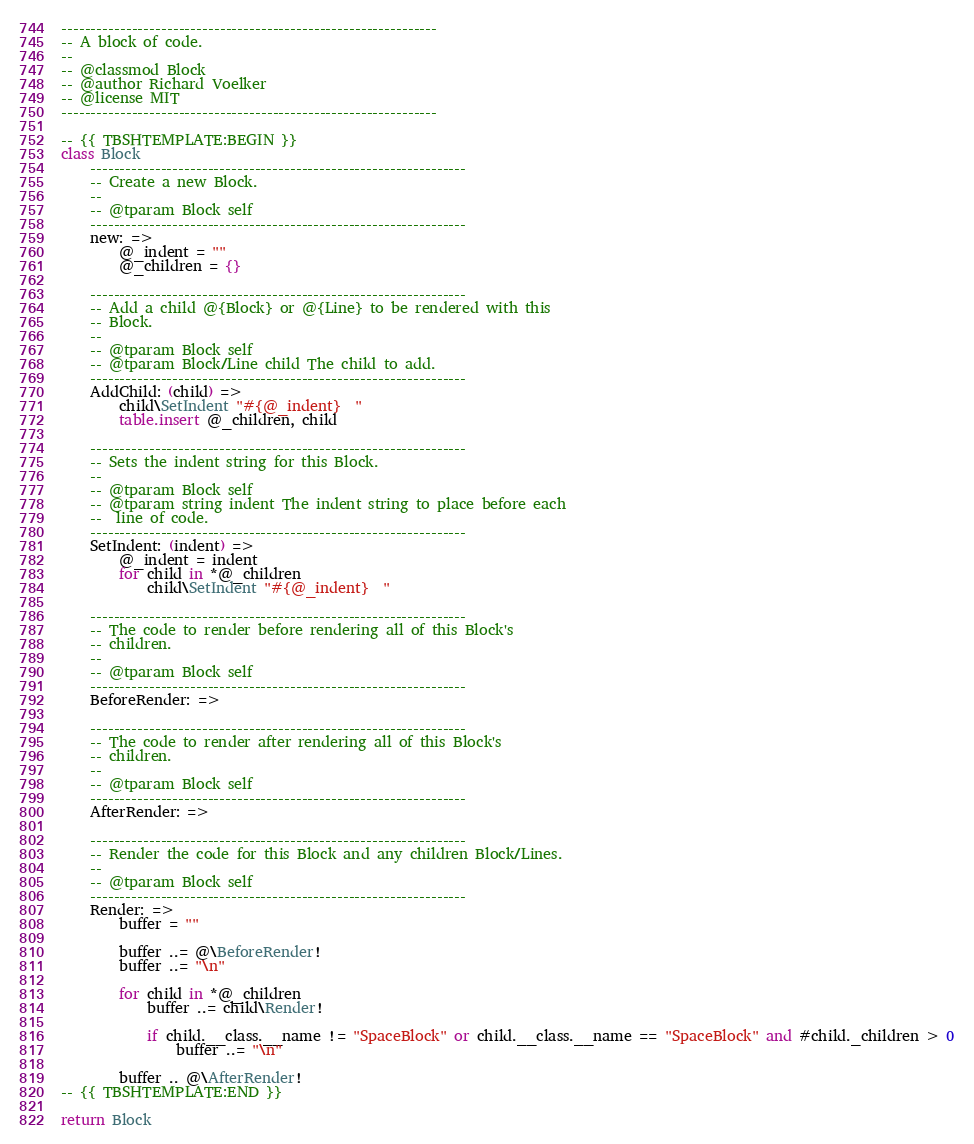Convert code to text. <code><loc_0><loc_0><loc_500><loc_500><_MoonScript_>----------------------------------------------------------------
-- A block of code.
--
-- @classmod Block
-- @author Richard Voelker
-- @license MIT
----------------------------------------------------------------

-- {{ TBSHTEMPLATE:BEGIN }}
class Block
	----------------------------------------------------------------
	-- Create a new Block.
	--
	-- @tparam Block self
	----------------------------------------------------------------
	new: =>
		@_indent = ""
		@_children = {}

	----------------------------------------------------------------
	-- Add a child @{Block} or @{Line} to be rendered with this
	-- Block.
	--
	-- @tparam Block self
	-- @tparam Block/Line child The child to add.
	----------------------------------------------------------------
	AddChild: (child) =>
		child\SetIndent "#{@_indent}  "
		table.insert @_children, child

	----------------------------------------------------------------
	-- Sets the indent string for this Block.
	--
	-- @tparam Block self
	-- @tparam string indent The indent string to place before each
	--	line of code.
	----------------------------------------------------------------
	SetIndent: (indent) =>
		@_indent = indent
		for child in *@_children
			child\SetIndent "#{@_indent}  "

	----------------------------------------------------------------
	-- The code to render before rendering all of this Block's
	-- children.
	--
	-- @tparam Block self
	----------------------------------------------------------------
	BeforeRender: =>

	----------------------------------------------------------------
	-- The code to render after rendering all of this Block's
	-- children.
	--
	-- @tparam Block self
	----------------------------------------------------------------
	AfterRender: =>

	----------------------------------------------------------------
	-- Render the code for this Block and any children Block/Lines.
	--
	-- @tparam Block self
	----------------------------------------------------------------
	Render: =>
		buffer = ""

		buffer ..= @\BeforeRender!
		buffer ..= "\n"

		for child in *@_children
			buffer ..= child\Render!

			if child.__class.__name != "SpaceBlock" or child.__class.__name == "SpaceBlock" and #child._children > 0
				buffer ..= "\n"

		buffer .. @\AfterRender!
-- {{ TBSHTEMPLATE:END }}

return Block
</code> 